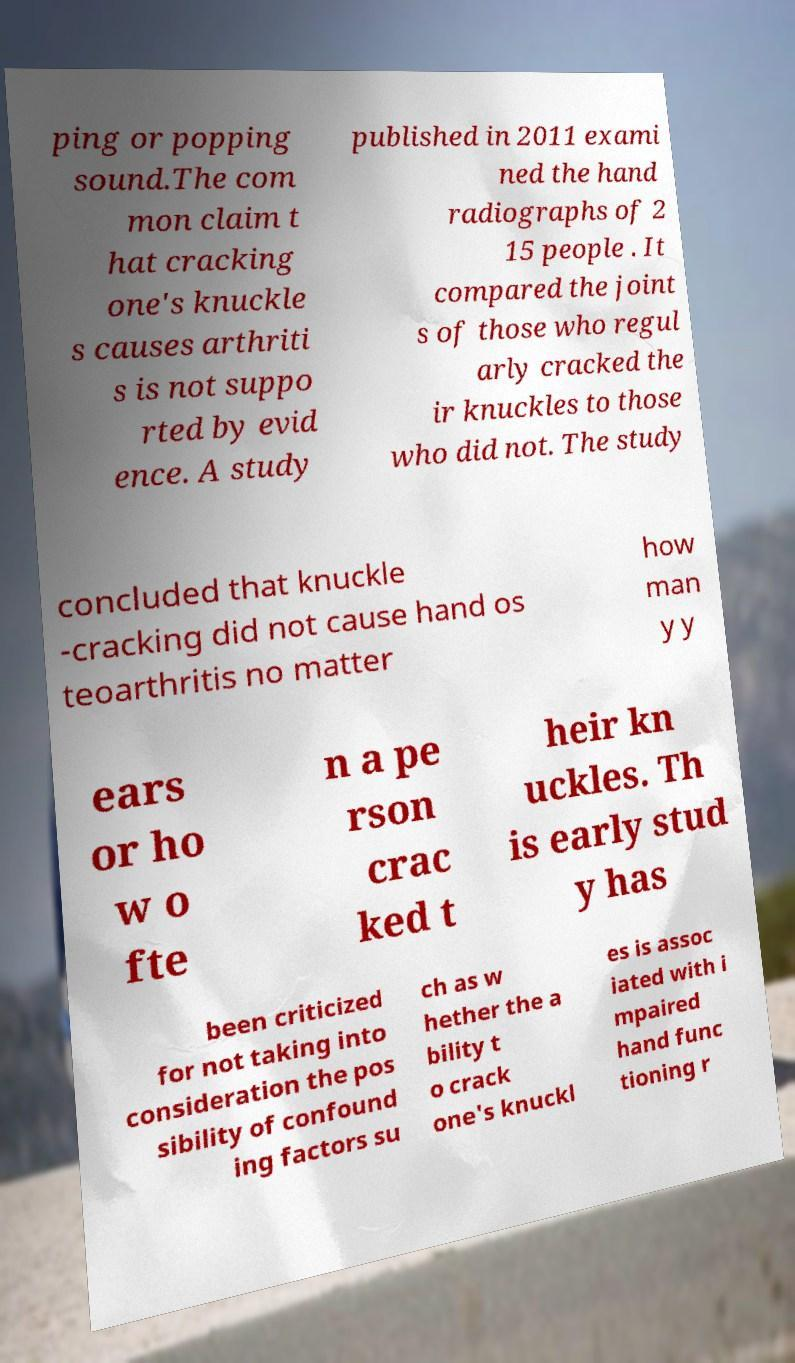Can you accurately transcribe the text from the provided image for me? ping or popping sound.The com mon claim t hat cracking one's knuckle s causes arthriti s is not suppo rted by evid ence. A study published in 2011 exami ned the hand radiographs of 2 15 people . It compared the joint s of those who regul arly cracked the ir knuckles to those who did not. The study concluded that knuckle -cracking did not cause hand os teoarthritis no matter how man y y ears or ho w o fte n a pe rson crac ked t heir kn uckles. Th is early stud y has been criticized for not taking into consideration the pos sibility of confound ing factors su ch as w hether the a bility t o crack one's knuckl es is assoc iated with i mpaired hand func tioning r 